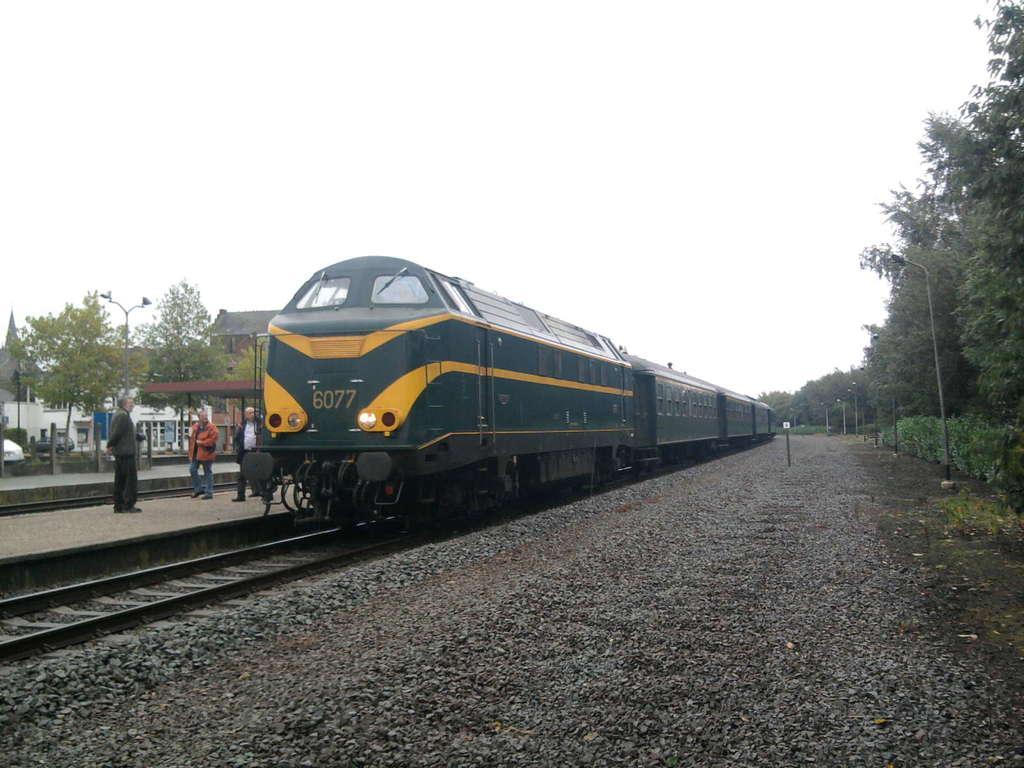Can you describe this image briefly? In this image we can see train on the railway track. Right side of the image trees and poles are there. Left side of the image three men are standing on the platform. Behind them trees, pole and houses are there. 